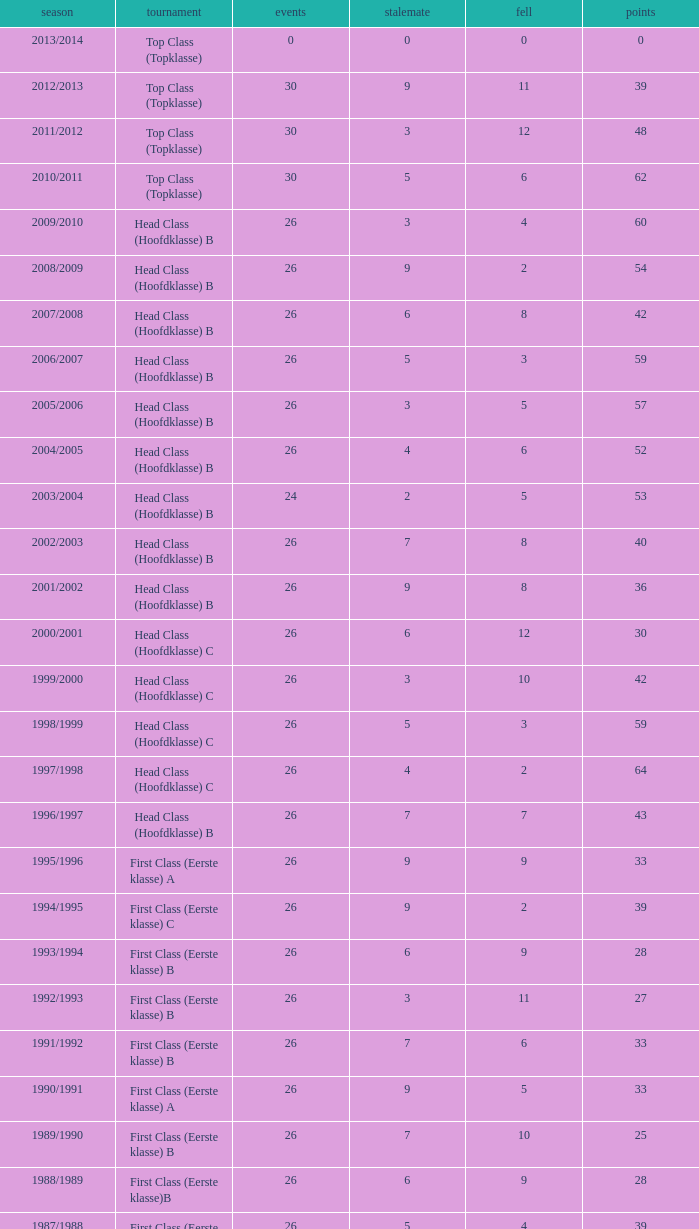What is the sum of the losses that a match score larger than 26, a points score of 62, and a draw greater than 5? None. 